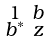<formula> <loc_0><loc_0><loc_500><loc_500>\begin{smallmatrix} 1 & b \\ b ^ { * } & z \end{smallmatrix}</formula> 